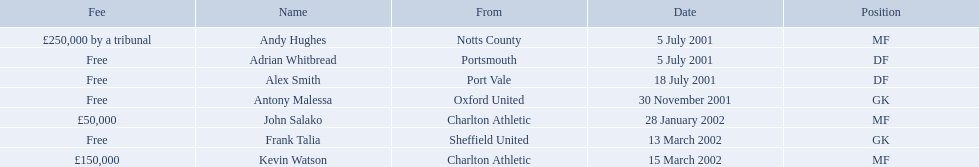Who are all the players? Andy Hughes, Adrian Whitbread, Alex Smith, Antony Malessa, John Salako, Frank Talia, Kevin Watson. What were their fees? £250,000 by a tribunal, Free, Free, Free, £50,000, Free, £150,000. And how much was kevin watson's fee? £150,000. 